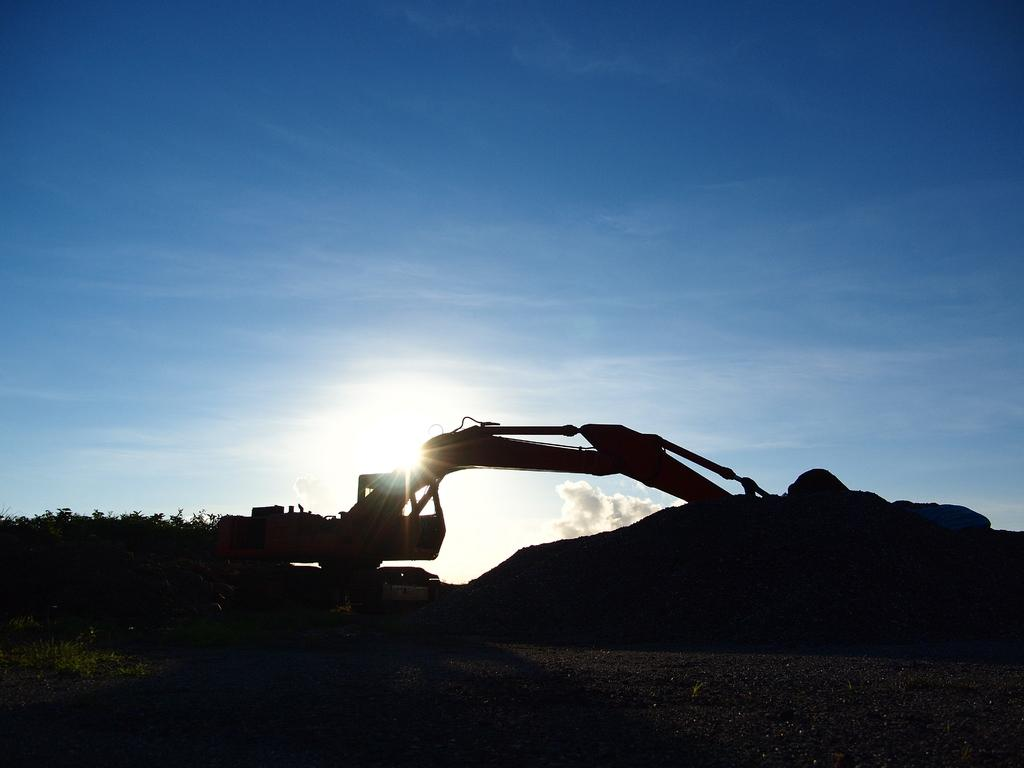What can be seen in the foreground of the picture? There are trees, soil, and machinery in the foreground of the picture. What type of vegetation is present in the foreground? Trees are present in the foreground of the picture. What is the condition of the soil in the foreground? Soil is present in the foreground of the picture. What is the weather like in the image? The sky is sunny in the image. What advice is being given by the trees in the foreground of the image? There is no indication in the image that the trees are giving advice; they are simply trees. What type of ink is being used by the machinery in the foreground of the image? There is no ink present in the image, as the machinery is not shown to be writing or drawing. 